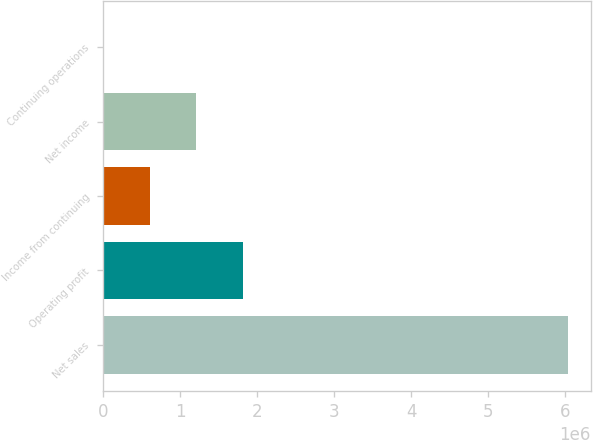Convert chart to OTSL. <chart><loc_0><loc_0><loc_500><loc_500><bar_chart><fcel>Net sales<fcel>Operating profit<fcel>Income from continuing<fcel>Net income<fcel>Continuing operations<nl><fcel>6.0282e+06<fcel>1.80846e+06<fcel>602821<fcel>1.20564e+06<fcel>1.41<nl></chart> 